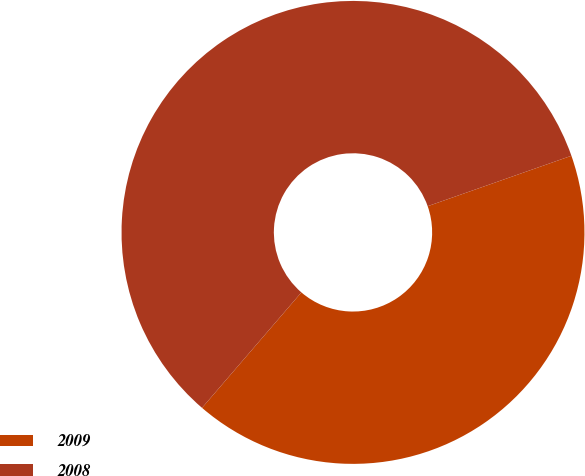Convert chart to OTSL. <chart><loc_0><loc_0><loc_500><loc_500><pie_chart><fcel>2009<fcel>2008<nl><fcel>41.68%<fcel>58.32%<nl></chart> 